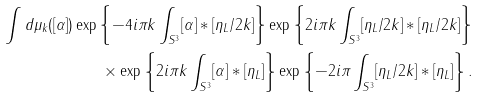Convert formula to latex. <formula><loc_0><loc_0><loc_500><loc_500>\int d \mu _ { k } ( [ \alpha ] ) \exp \left \{ - 4 i \pi k \int _ { S ^ { 3 } } [ \alpha ] * [ \eta _ { L } / 2 k ] \right \} \exp \left \{ 2 i \pi k \int _ { S ^ { 3 } } [ \eta _ { L } / 2 k ] * [ \eta _ { L } / 2 k ] \right \} \\ { } \times \exp \left \{ 2 i \pi k \int _ { S ^ { 3 } } [ \alpha ] \ast [ \eta _ { L } ] \right \} \exp \left \{ - 2 i \pi \int _ { S ^ { 3 } } [ \eta _ { L } / 2 k ] \ast [ \eta _ { L } ] \right \} .</formula> 